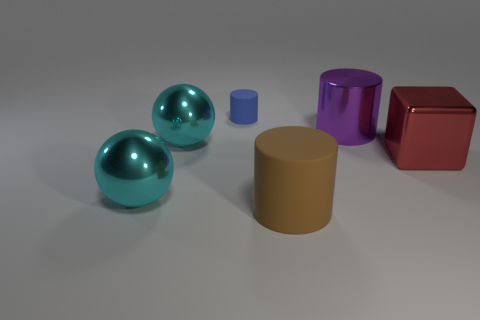What number of rubber things are to the right of the blue matte object and to the left of the brown cylinder?
Your response must be concise. 0. What is the material of the large cyan object that is behind the big cube?
Your answer should be very brief. Metal. What size is the other cylinder that is made of the same material as the brown cylinder?
Your answer should be compact. Small. How many objects are either purple objects or big cyan spheres?
Make the answer very short. 3. What is the color of the matte cylinder that is in front of the red shiny cube?
Keep it short and to the point. Brown. There is a purple metal thing that is the same shape as the brown object; what is its size?
Your answer should be compact. Large. What number of things are either matte cylinders left of the brown thing or big things that are left of the large purple shiny cylinder?
Your answer should be very brief. 4. There is a thing that is both to the right of the small blue matte object and in front of the red cube; what is its size?
Your answer should be compact. Large. There is a small matte object; does it have the same shape as the large cyan metal thing that is in front of the large red shiny block?
Make the answer very short. No. What number of things are either matte things that are to the right of the small blue matte cylinder or brown things?
Your answer should be compact. 1. 